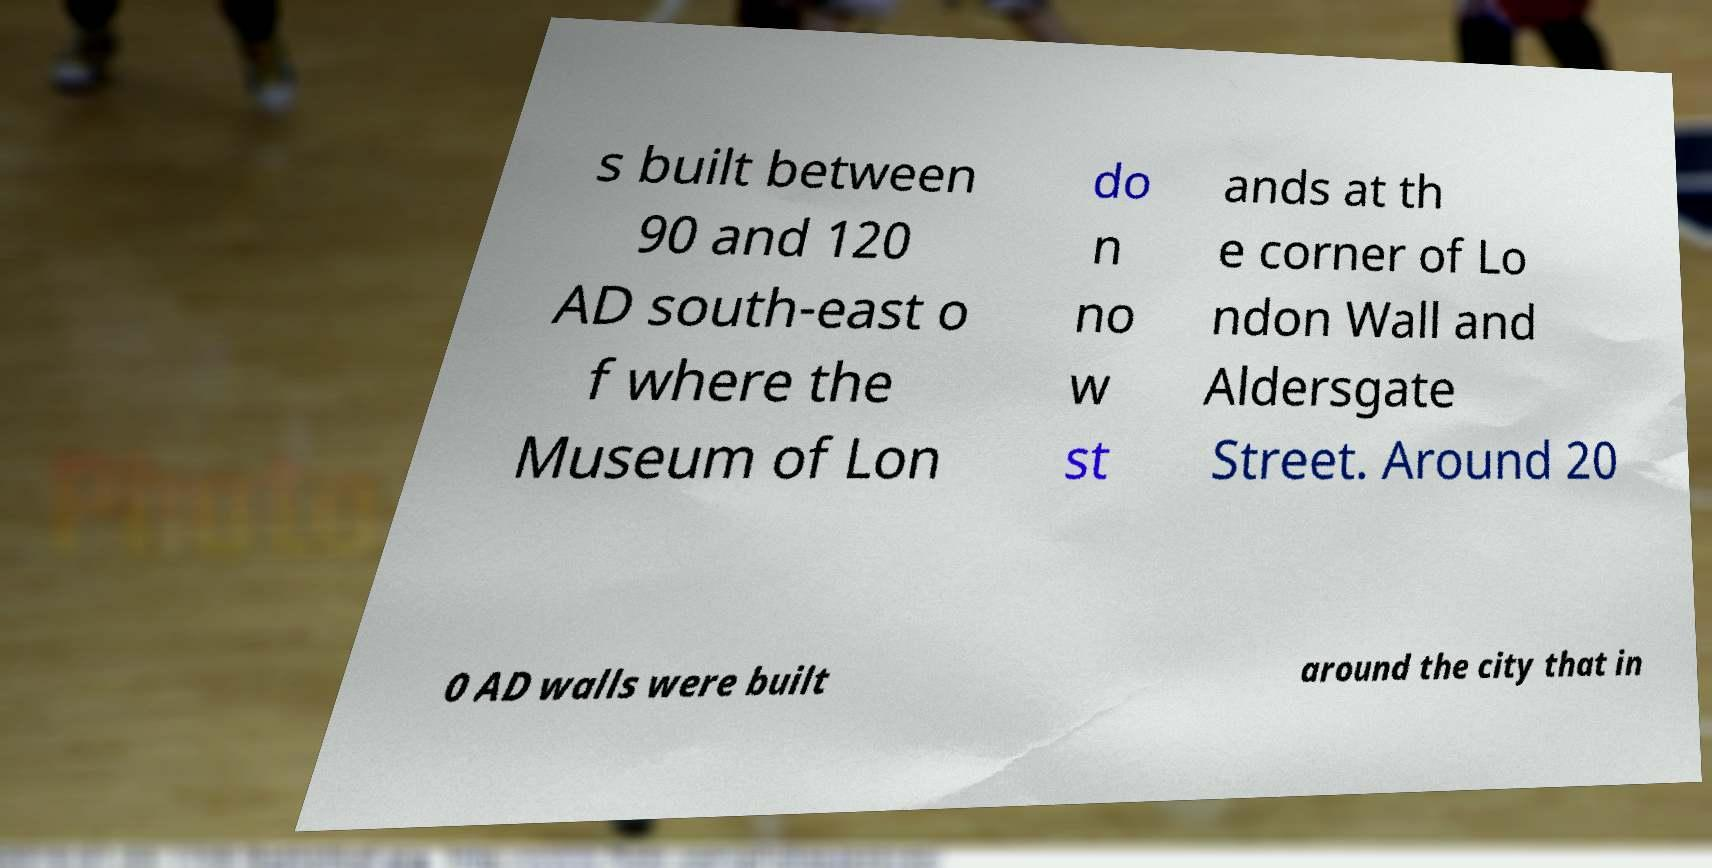Please read and relay the text visible in this image. What does it say? s built between 90 and 120 AD south-east o f where the Museum of Lon do n no w st ands at th e corner of Lo ndon Wall and Aldersgate Street. Around 20 0 AD walls were built around the city that in 